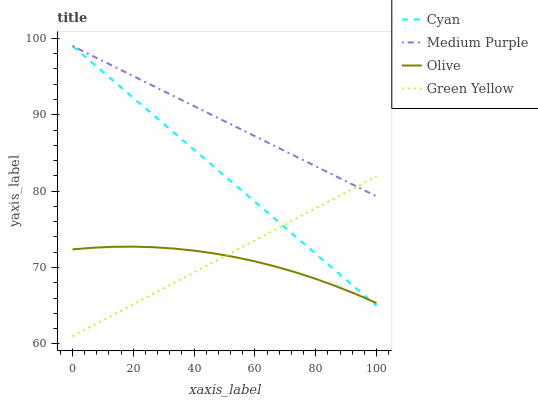Does Cyan have the minimum area under the curve?
Answer yes or no. No. Does Cyan have the maximum area under the curve?
Answer yes or no. No. Is Green Yellow the smoothest?
Answer yes or no. No. Is Green Yellow the roughest?
Answer yes or no. No. Does Cyan have the lowest value?
Answer yes or no. No. Does Green Yellow have the highest value?
Answer yes or no. No. Is Olive less than Medium Purple?
Answer yes or no. Yes. Is Medium Purple greater than Olive?
Answer yes or no. Yes. Does Olive intersect Medium Purple?
Answer yes or no. No. 